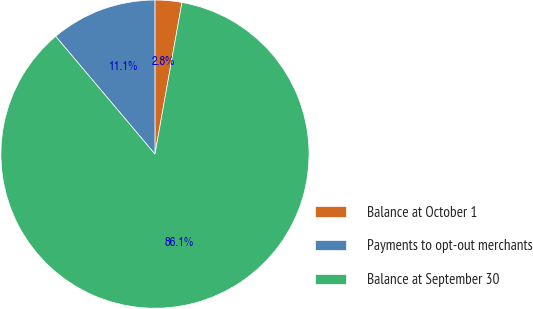Convert chart to OTSL. <chart><loc_0><loc_0><loc_500><loc_500><pie_chart><fcel>Balance at October 1<fcel>Payments to opt-out merchants<fcel>Balance at September 30<nl><fcel>2.81%<fcel>11.14%<fcel>86.05%<nl></chart> 